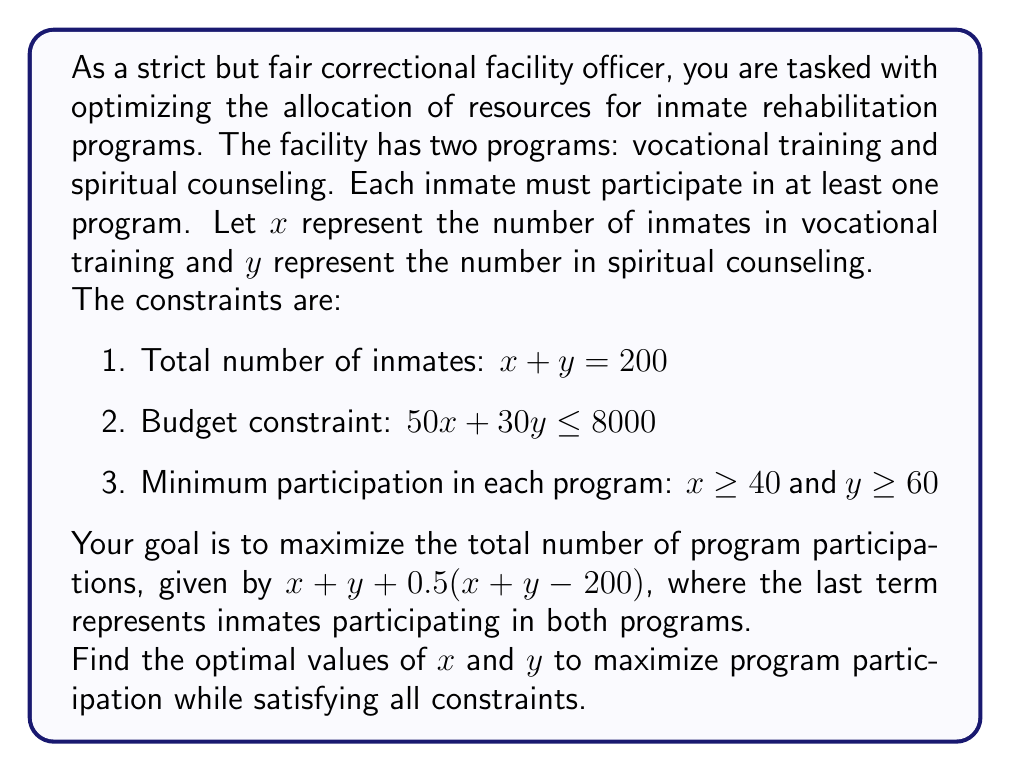Can you answer this question? Let's approach this problem step-by-step:

1) First, we need to set up our objective function. We want to maximize:
   $$f(x,y) = x + y + 0.5(x + y - 200) = 1.5x + 1.5y - 100$$

2) Now, let's list our constraints:
   a) $x + y = 200$
   b) $50x + 30y \leq 8000$
   c) $x \geq 40$
   d) $y \geq 60$

3) From constraint (a), we can express $y$ in terms of $x$:
   $$y = 200 - x$$

4) Substituting this into our objective function:
   $$f(x) = 1.5x + 1.5(200 - x) - 100 = 300 - 100 = 200$$

   This shows that the total value of the objective function is constant, regardless of $x$ and $y$. Therefore, we just need to find feasible values of $x$ and $y$ that satisfy all constraints.

5) Let's substitute $y = 200 - x$ into constraint (b):
   $$50x + 30(200 - x) \leq 8000$$
   $$50x + 6000 - 30x \leq 8000$$
   $$20x \leq 2000$$
   $$x \leq 100$$

6) Combining this with constraints (c) and (d):
   $$40 \leq x \leq 100$$
   $$60 \leq y \leq 160$$

7) Any values of $x$ and $y$ within these ranges that sum to 200 will maximize the objective function. To choose a specific solution, we can consider the budget constraint more closely:

   $$50x + 30y = 50x + 30(200 - x) = 6000 + 20x \leq 8000$$

   This is satisfied when $x = 100$ and $y = 100$.

Therefore, the optimal solution is to have 100 inmates in vocational training and 100 in spiritual counseling.
Answer: The optimal allocation is $x = 100$ (vocational training) and $y = 100$ (spiritual counseling). 